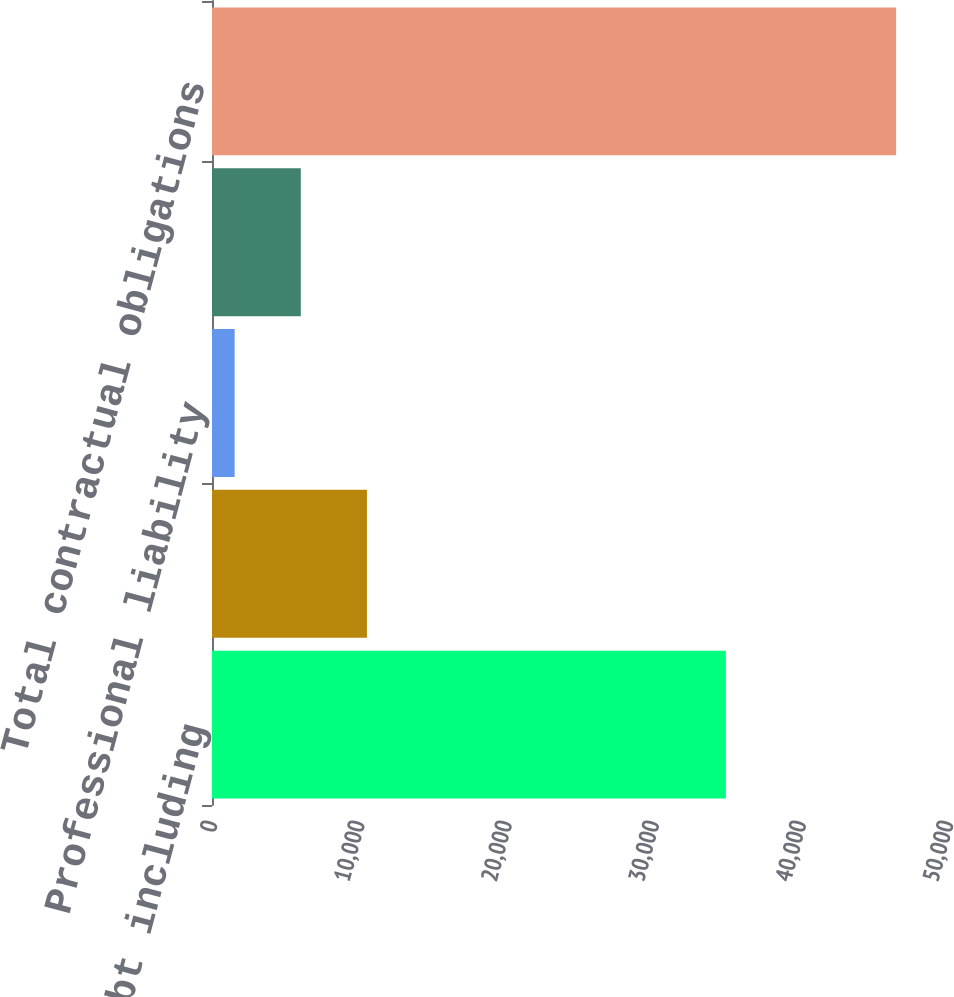<chart> <loc_0><loc_0><loc_500><loc_500><bar_chart><fcel>Long-term debt including<fcel>Loans outstanding under the<fcel>Professional liability<fcel>Operating leases(d)<fcel>Total contractual obligations<nl><fcel>34910<fcel>10526<fcel>1539<fcel>6032.5<fcel>46474<nl></chart> 